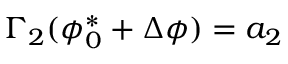<formula> <loc_0><loc_0><loc_500><loc_500>\Gamma _ { 2 } ( \phi _ { 0 } ^ { * } + \Delta \phi ) = a _ { 2 }</formula> 